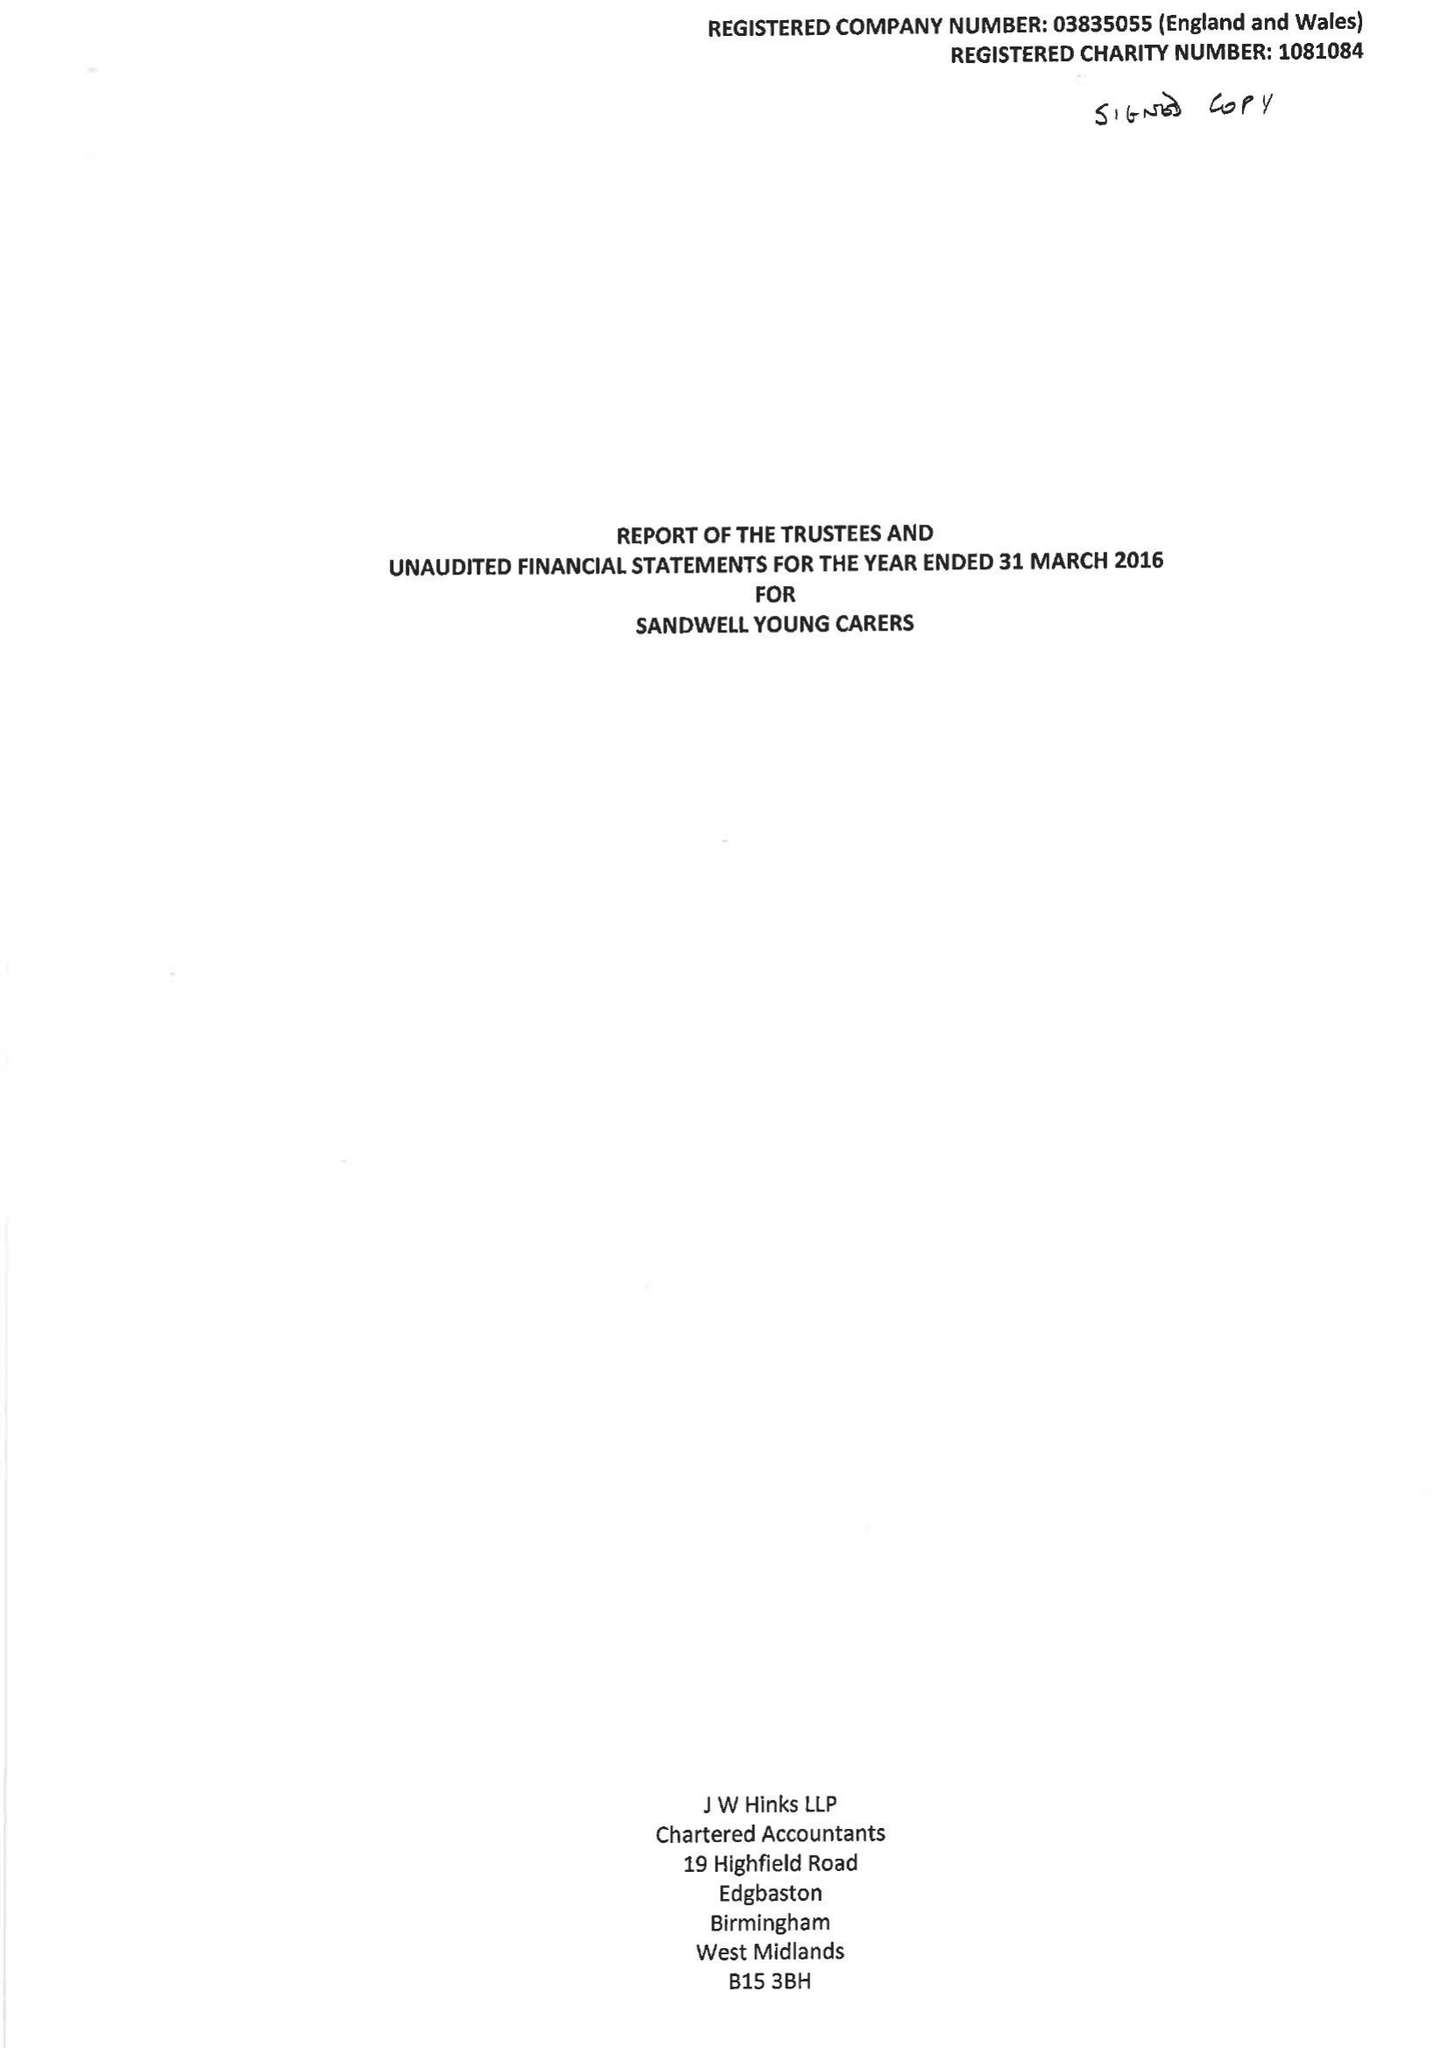What is the value for the address__street_line?
Answer the question using a single word or phrase. 44 BRATT STREET 